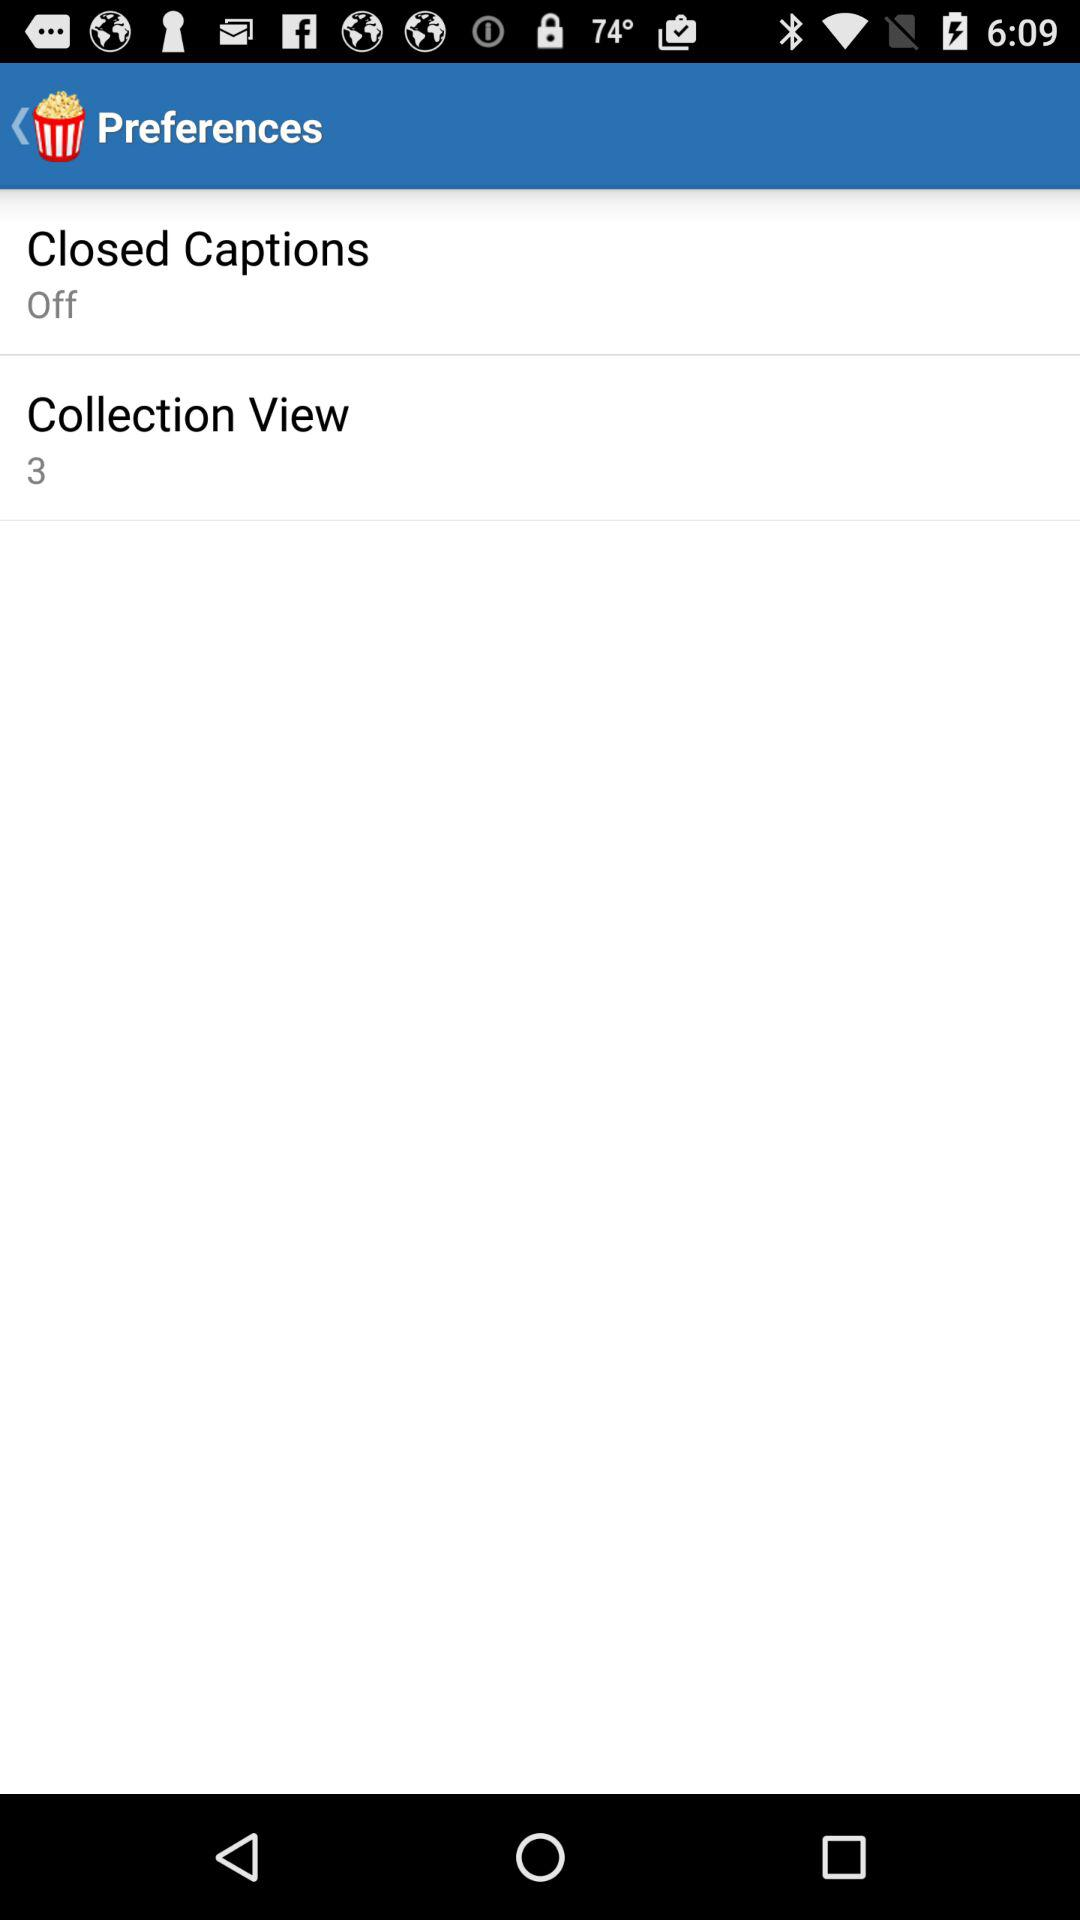How many items are there in total in the "Collection View"? There are 3 items in total in the "Collection View". 